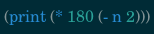Convert code to text. <code><loc_0><loc_0><loc_500><loc_500><_Scheme_>(print (* 180 (- n 2)))
</code> 